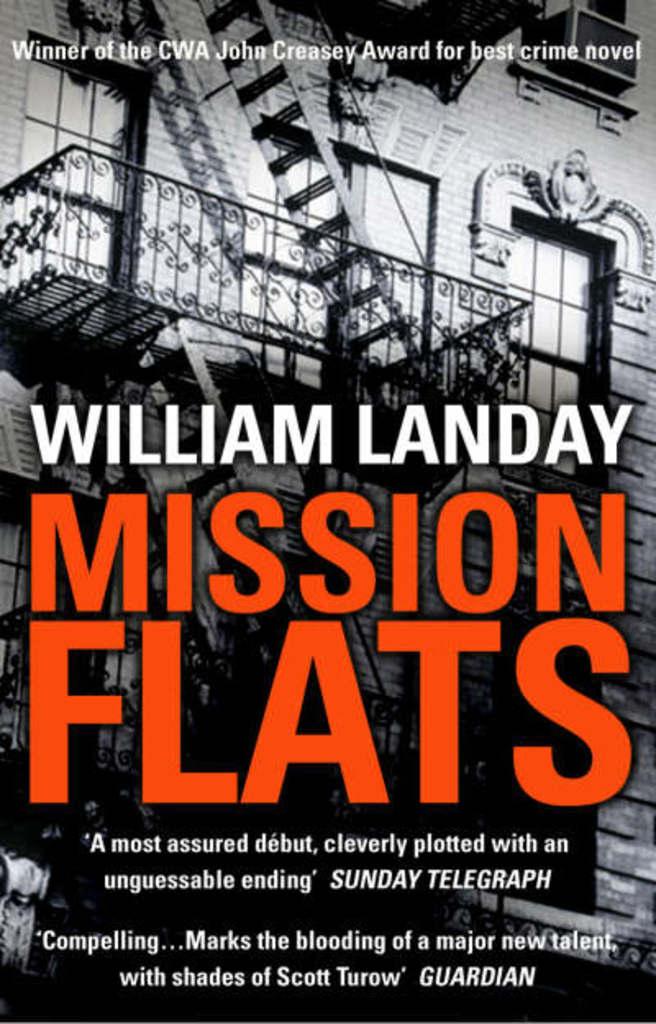What's the name of the book?
Your answer should be compact. Mission flats. Who wrote mission flats?
Provide a succinct answer. William landay. 